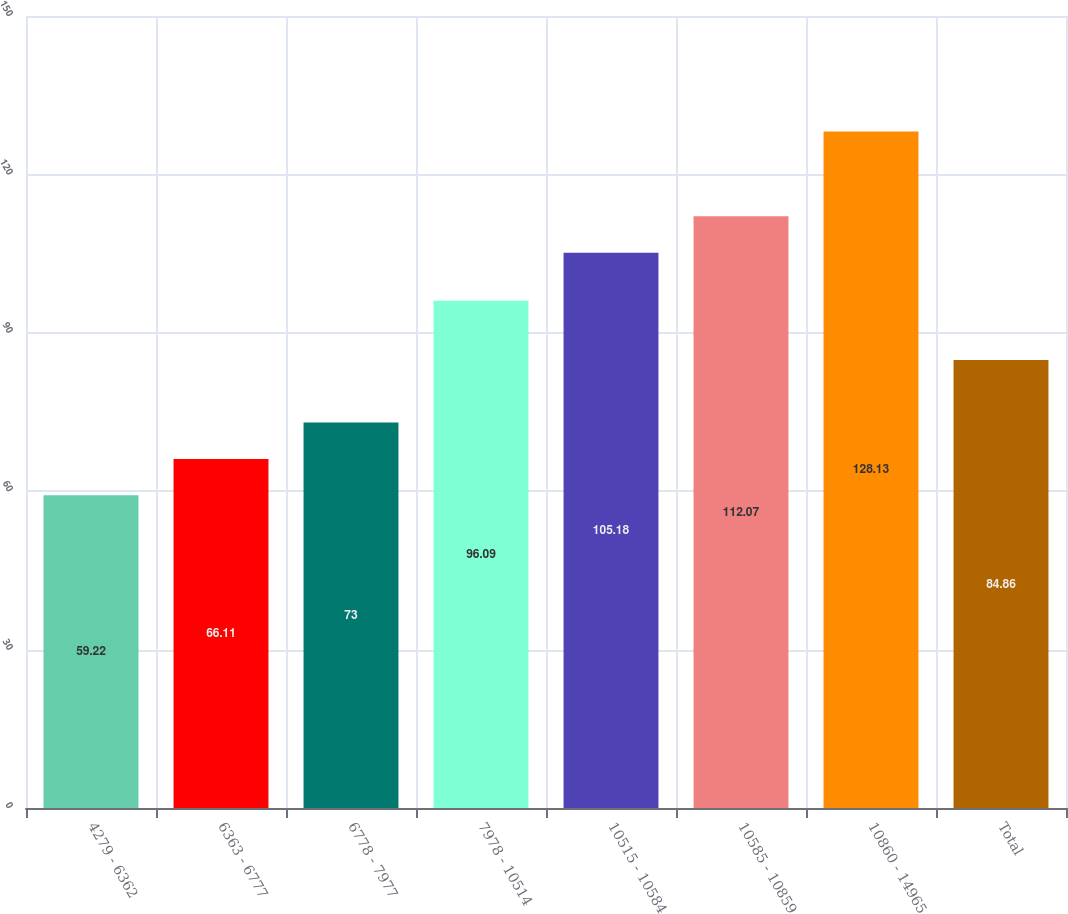<chart> <loc_0><loc_0><loc_500><loc_500><bar_chart><fcel>4279 - 6362<fcel>6363 - 6777<fcel>6778 - 7977<fcel>7978 - 10514<fcel>10515 - 10584<fcel>10585 - 10859<fcel>10860 - 14965<fcel>Total<nl><fcel>59.22<fcel>66.11<fcel>73<fcel>96.09<fcel>105.18<fcel>112.07<fcel>128.13<fcel>84.86<nl></chart> 